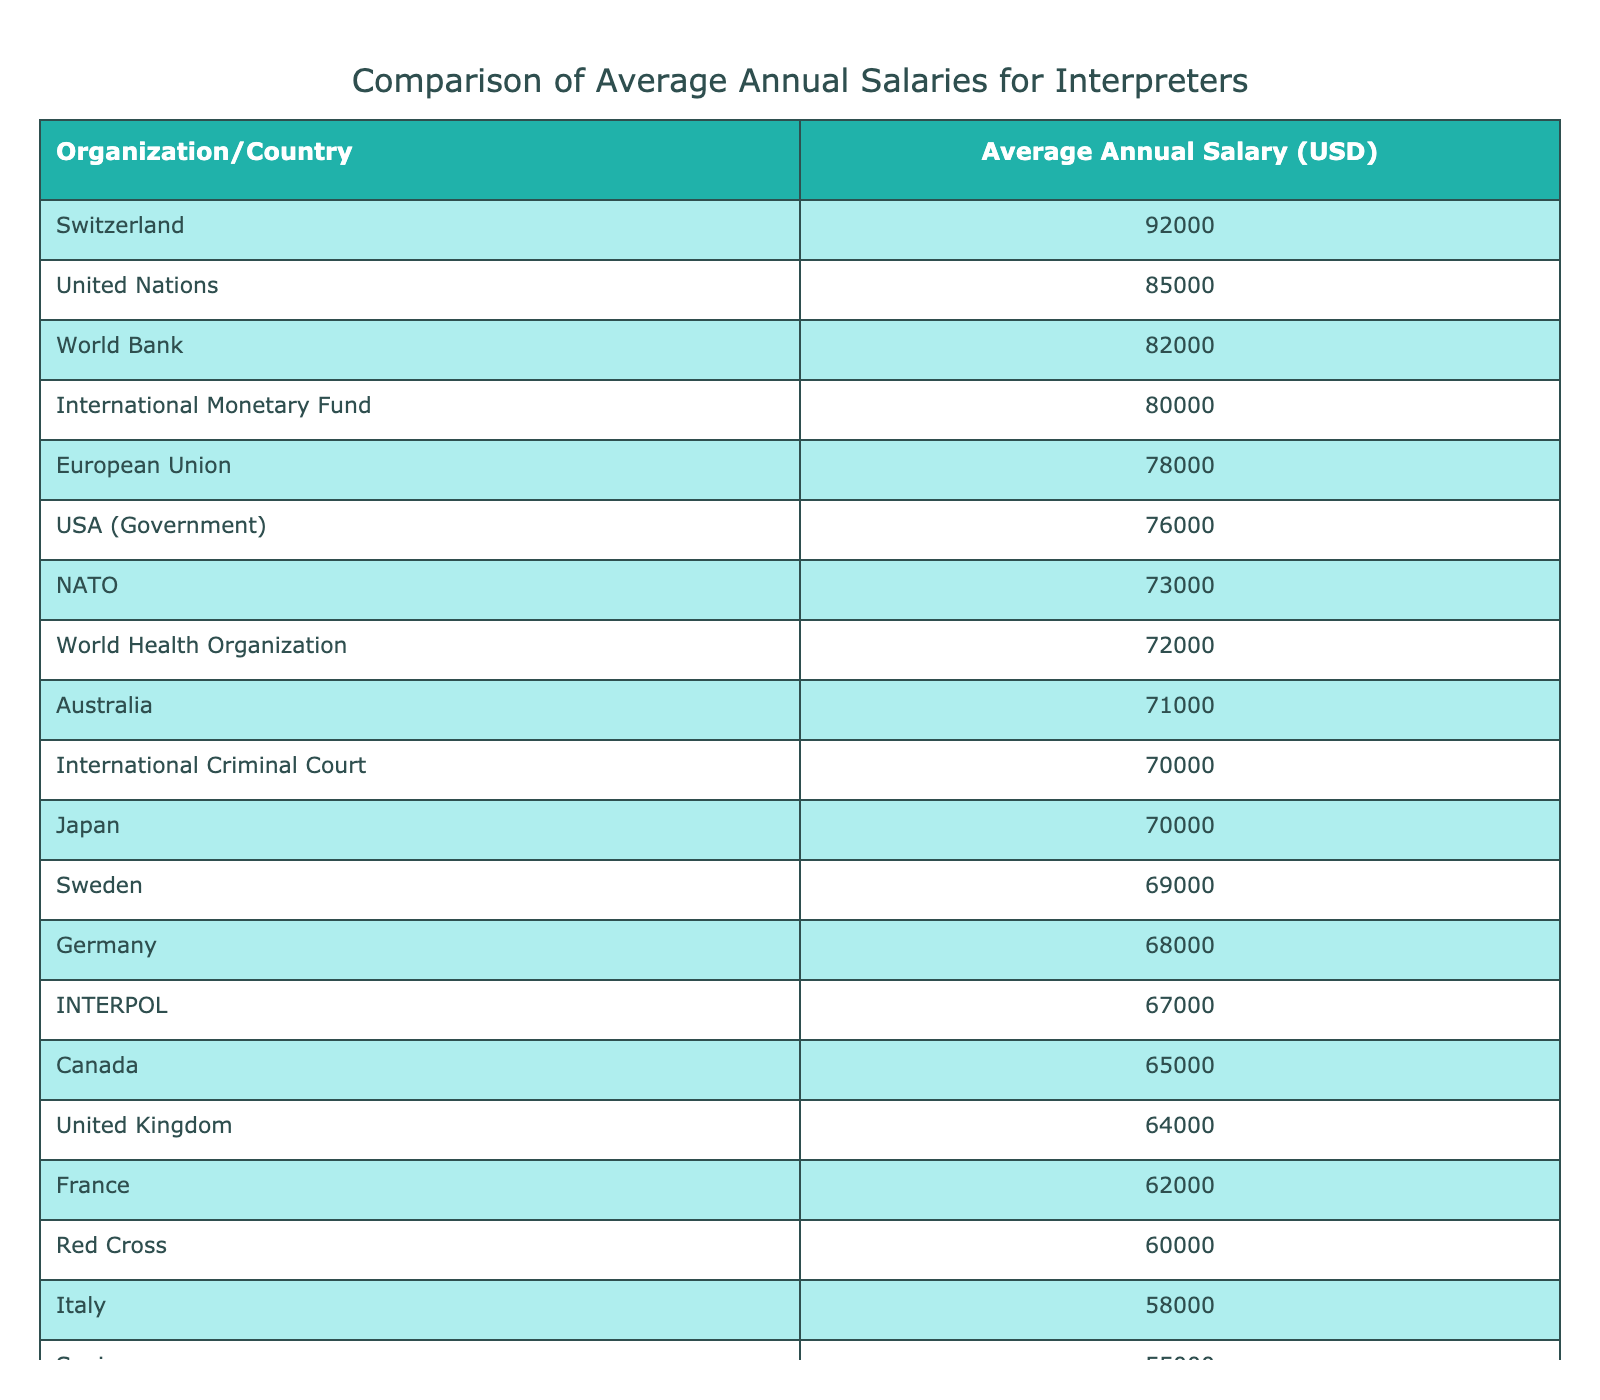What is the average annual salary for interpreters at the United Nations? According to the table, the United Nations has an average annual salary of 85,000 USD for interpreters.
Answer: 85,000 USD Which country has the highest average annual salary for interpreters? The table shows that Switzerland has the highest average annual salary, at 92,000 USD.
Answer: Switzerland What is the difference in average annual salary between the World Bank and the International Criminal Court? The World Bank has an average salary of 82,000 USD while the International Criminal Court has 70,000 USD. The difference is 82,000 - 70,000 = 12,000 USD.
Answer: 12,000 USD Is the average salary for interpreters in Canada higher than in Spain? The average salary in Canada is 65,000 USD and in Spain, it is 55,000 USD. Since 65,000 is greater than 55,000, the answer is yes.
Answer: Yes What is the average salary of interpreters from the top three organizations listed in the table? The top three organizations are the United Nations (85,000 USD), the World Bank (82,000 USD), and the European Union (78,000 USD). The average is calculated as (85,000 + 82,000 + 78,000) / 3 = 81,666.67 USD.
Answer: 81,666.67 USD How many organizations have an average salary greater than 70,000 USD? By examining the table, the organizations with salaries above 70,000 are the United Nations, European Union, World Bank, International Monetary Fund, Switzerland, and USA (Government). That adds up to 6 organizations.
Answer: 6 Which country has a lower average salary for interpreters, the United Kingdom or Italy? The table indicates that the United Kingdom has a salary of 64,000 USD and Italy has 58,000 USD. Since 58,000 is less than 64,000, Italy has the lower salary.
Answer: Italy What is the median average annual salary for the countries listed? To find the median, we first need to order the salary in ascending order. The median salary is the middle value of the ordered list. The middle values for the 14 salaries would be the 7th and 8th values, which are 67,000 and 68,000. The median is (67,000 + 68,000) / 2 = 67,500 USD.
Answer: 67,500 USD Are there any organizations with an average salary below 60,000 USD? Checking the table, the organizations Red Cross (60,000 USD), Spain (55,000 USD), and France (62,000 USD) show salaries below 60,000. Thus, there are indeed organizations with salaries below this amount.
Answer: Yes 